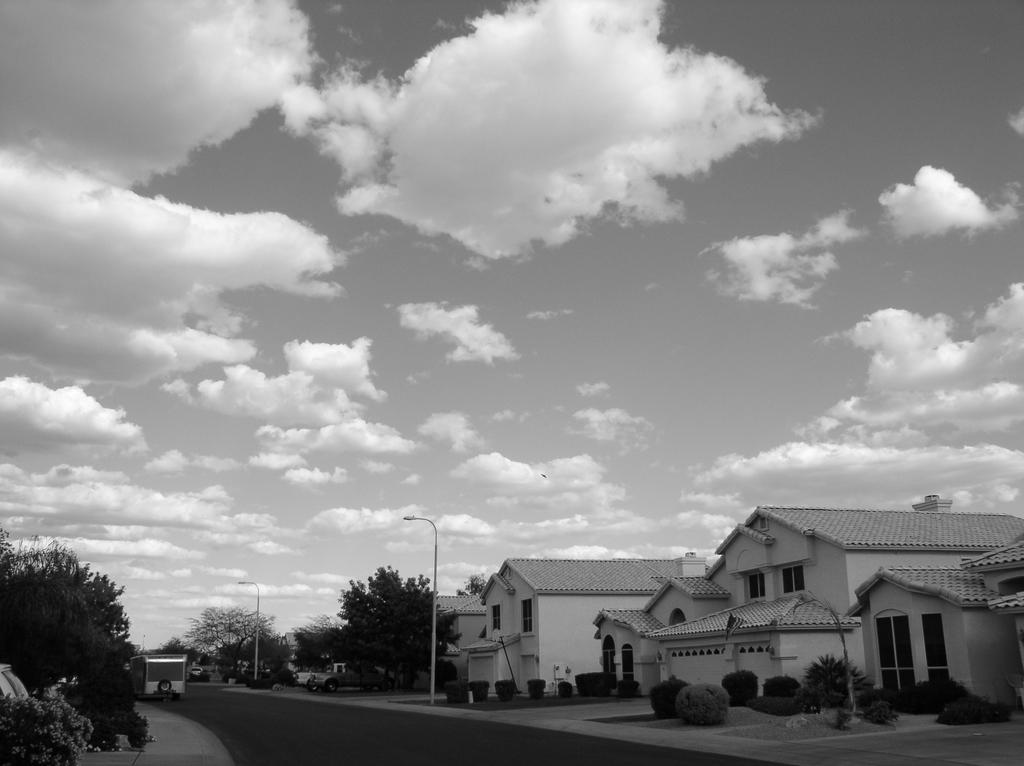Could you give a brief overview of what you see in this image? This picture consists of a road , on the road I can see vehicles and street light poles and on the left side there are houses , in front of houses I can see trees and bushes visible and on the left side trees visible ,at the top I can see the sky and the sky is cloudy 